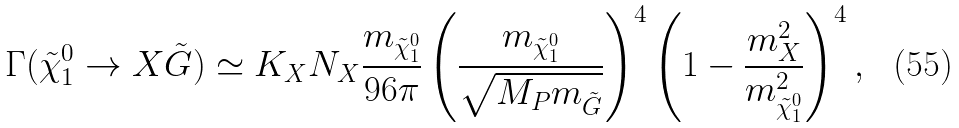Convert formula to latex. <formula><loc_0><loc_0><loc_500><loc_500>\Gamma ( \tilde { \chi } _ { 1 } ^ { 0 } \to X \tilde { G } ) \simeq K _ { X } N _ { X } \frac { m _ { \tilde { \chi } _ { 1 } ^ { 0 } } } { 9 6 \pi } \left ( \frac { m _ { \tilde { \chi } _ { 1 } ^ { 0 } } } { \sqrt { M _ { P } m _ { \tilde { G } } } } \right ) ^ { 4 } \left ( 1 - \frac { m _ { X } ^ { 2 } } { m _ { \tilde { \chi } _ { 1 } ^ { 0 } } ^ { 2 } } \right ) ^ { 4 } ,</formula> 